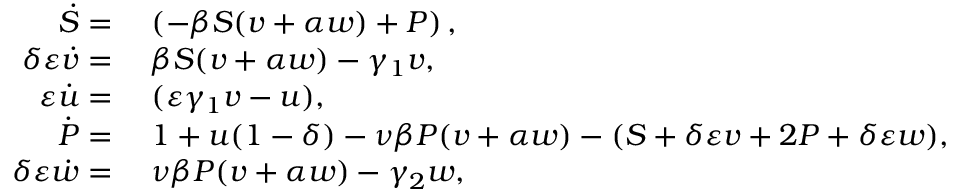Convert formula to latex. <formula><loc_0><loc_0><loc_500><loc_500>\begin{array} { r l } { \ D o t { S } = } & { \, \left ( - \beta S ( v + \alpha w ) + P \right ) , } \\ { \delta \varepsilon \ D o t { v } = } & { \, \beta S ( v + \alpha w ) - \gamma _ { 1 } v , } \\ { \varepsilon \ D o t { u } = } & { \, ( \varepsilon \gamma _ { 1 } v - u ) , } \\ { \ D o t { P } = } & { \, 1 + u ( 1 - \delta ) - \nu \beta P ( v + \alpha w ) - ( S + \delta \varepsilon v + 2 P + \delta \varepsilon w ) , } \\ { \delta \varepsilon \ D o t { w } = } & { \, \nu \beta P ( v + \alpha w ) - \gamma _ { 2 } w , } \end{array}</formula> 